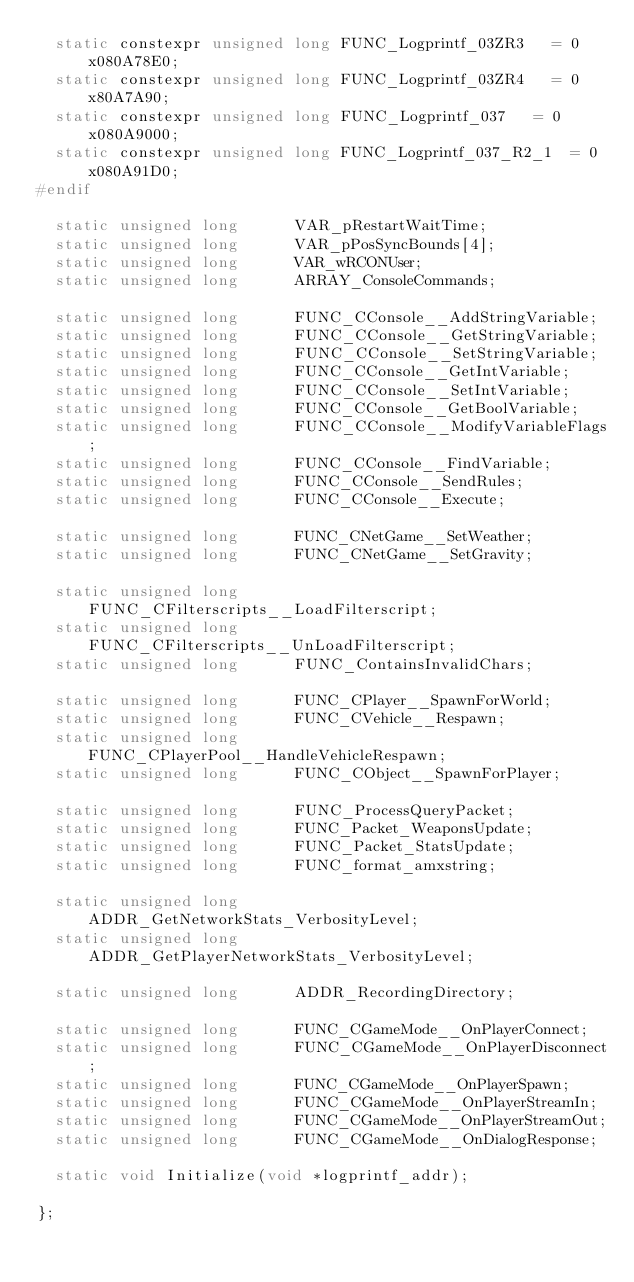Convert code to text. <code><loc_0><loc_0><loc_500><loc_500><_C_>	static constexpr unsigned long FUNC_Logprintf_03ZR3		= 0x080A78E0;
	static constexpr unsigned long FUNC_Logprintf_03ZR4		= 0x80A7A90;
	static constexpr unsigned long FUNC_Logprintf_037		= 0x080A9000;
	static constexpr unsigned long FUNC_Logprintf_037_R2_1	= 0x080A91D0;
#endif

	static unsigned long			VAR_pRestartWaitTime;
	static unsigned long			VAR_pPosSyncBounds[4];
	static unsigned long			VAR_wRCONUser;
	static unsigned long			ARRAY_ConsoleCommands;

	static unsigned long			FUNC_CConsole__AddStringVariable;
	static unsigned long			FUNC_CConsole__GetStringVariable;
	static unsigned long			FUNC_CConsole__SetStringVariable;
	static unsigned long			FUNC_CConsole__GetIntVariable;
	static unsigned long			FUNC_CConsole__SetIntVariable;
	static unsigned long			FUNC_CConsole__GetBoolVariable;
	static unsigned long			FUNC_CConsole__ModifyVariableFlags;
	static unsigned long			FUNC_CConsole__FindVariable;
	static unsigned long			FUNC_CConsole__SendRules;
	static unsigned long			FUNC_CConsole__Execute;

	static unsigned long			FUNC_CNetGame__SetWeather;
	static unsigned long			FUNC_CNetGame__SetGravity;

	static unsigned long			FUNC_CFilterscripts__LoadFilterscript;
	static unsigned long			FUNC_CFilterscripts__UnLoadFilterscript;
	static unsigned long			FUNC_ContainsInvalidChars;

	static unsigned long			FUNC_CPlayer__SpawnForWorld;
	static unsigned long			FUNC_CVehicle__Respawn;
	static unsigned long			FUNC_CPlayerPool__HandleVehicleRespawn;
	static unsigned long			FUNC_CObject__SpawnForPlayer;

	static unsigned long			FUNC_ProcessQueryPacket;
	static unsigned long			FUNC_Packet_WeaponsUpdate;
	static unsigned long			FUNC_Packet_StatsUpdate;
	static unsigned long			FUNC_format_amxstring;

	static unsigned long			ADDR_GetNetworkStats_VerbosityLevel;
	static unsigned long			ADDR_GetPlayerNetworkStats_VerbosityLevel;

	static unsigned long			ADDR_RecordingDirectory;

	static unsigned long			FUNC_CGameMode__OnPlayerConnect;
	static unsigned long			FUNC_CGameMode__OnPlayerDisconnect;
	static unsigned long			FUNC_CGameMode__OnPlayerSpawn;
	static unsigned long			FUNC_CGameMode__OnPlayerStreamIn;
	static unsigned long			FUNC_CGameMode__OnPlayerStreamOut;
	static unsigned long			FUNC_CGameMode__OnDialogResponse;

	static void	Initialize(void *logprintf_addr);

};
</code> 